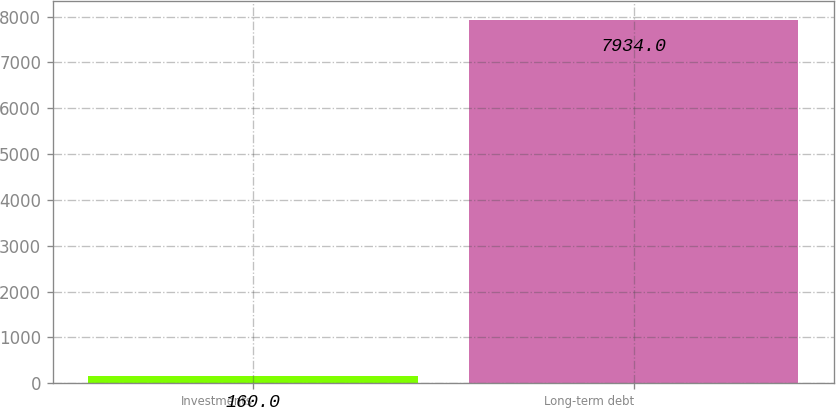Convert chart to OTSL. <chart><loc_0><loc_0><loc_500><loc_500><bar_chart><fcel>Investments<fcel>Long-term debt<nl><fcel>160<fcel>7934<nl></chart> 